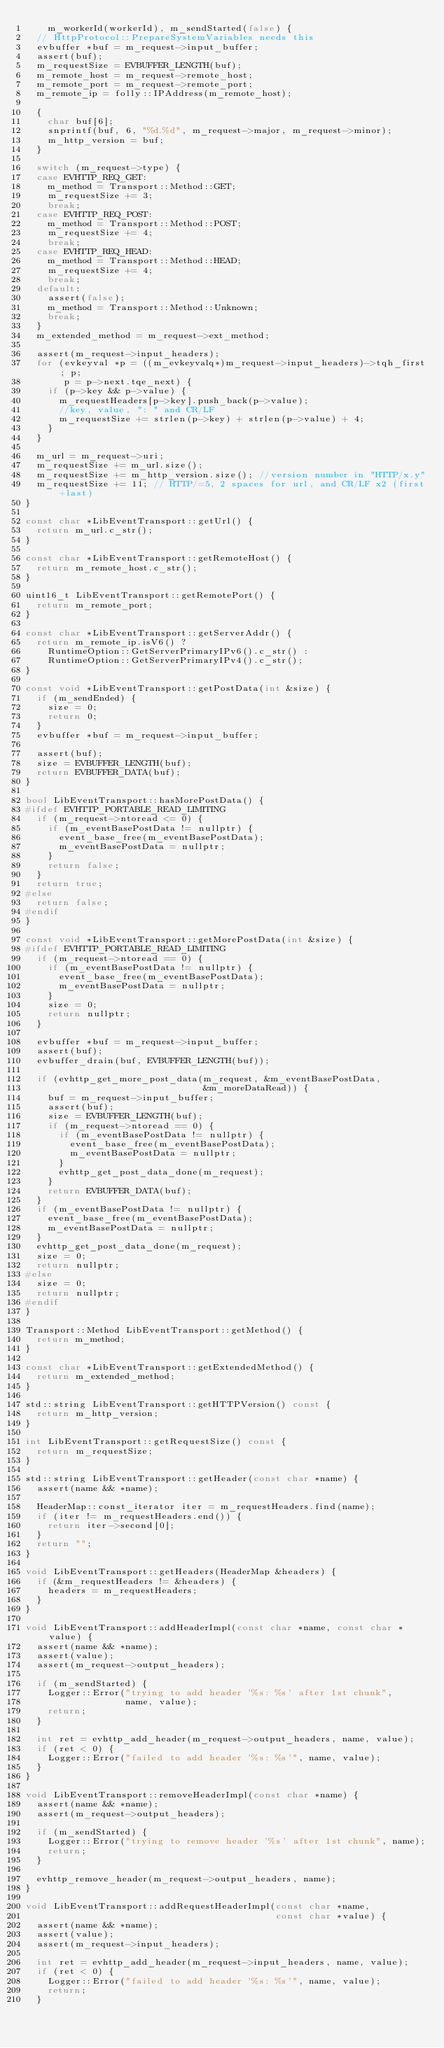Convert code to text. <code><loc_0><loc_0><loc_500><loc_500><_C++_>    m_workerId(workerId), m_sendStarted(false) {
  // HttpProtocol::PrepareSystemVariables needs this
  evbuffer *buf = m_request->input_buffer;
  assert(buf);
  m_requestSize = EVBUFFER_LENGTH(buf);
  m_remote_host = m_request->remote_host;
  m_remote_port = m_request->remote_port;
  m_remote_ip = folly::IPAddress(m_remote_host);

  {
    char buf[6];
    snprintf(buf, 6, "%d.%d", m_request->major, m_request->minor);
    m_http_version = buf;
  }

  switch (m_request->type) {
  case EVHTTP_REQ_GET:
    m_method = Transport::Method::GET;
    m_requestSize += 3;
    break;
  case EVHTTP_REQ_POST:
    m_method = Transport::Method::POST;
    m_requestSize += 4;
    break;
  case EVHTTP_REQ_HEAD:
    m_method = Transport::Method::HEAD;
    m_requestSize += 4;
    break;
  default:
    assert(false);
    m_method = Transport::Method::Unknown;
    break;
  }
  m_extended_method = m_request->ext_method;

  assert(m_request->input_headers);
  for (evkeyval *p = ((m_evkeyvalq*)m_request->input_headers)->tqh_first; p;
       p = p->next.tqe_next) {
    if (p->key && p->value) {
      m_requestHeaders[p->key].push_back(p->value);
      //key, value, ": " and CR/LF
      m_requestSize += strlen(p->key) + strlen(p->value) + 4;
    }
  }

  m_url = m_request->uri;
  m_requestSize += m_url.size();
  m_requestSize += m_http_version.size(); //version number in "HTTP/x.y"
  m_requestSize += 11; // HTTP/=5, 2 spaces for url, and CR/LF x2 (first+last)
}

const char *LibEventTransport::getUrl() {
  return m_url.c_str();
}

const char *LibEventTransport::getRemoteHost() {
  return m_remote_host.c_str();
}

uint16_t LibEventTransport::getRemotePort() {
  return m_remote_port;
}

const char *LibEventTransport::getServerAddr() {
  return m_remote_ip.isV6() ?
    RuntimeOption::GetServerPrimaryIPv6().c_str() :
    RuntimeOption::GetServerPrimaryIPv4().c_str();
}

const void *LibEventTransport::getPostData(int &size) {
  if (m_sendEnded) {
    size = 0;
    return 0;
  }
  evbuffer *buf = m_request->input_buffer;

  assert(buf);
  size = EVBUFFER_LENGTH(buf);
  return EVBUFFER_DATA(buf);
}

bool LibEventTransport::hasMorePostData() {
#ifdef EVHTTP_PORTABLE_READ_LIMITING
  if (m_request->ntoread <= 0) {
    if (m_eventBasePostData != nullptr) {
      event_base_free(m_eventBasePostData);
      m_eventBasePostData = nullptr;
    }
    return false;
  }
  return true;
#else
  return false;
#endif
}

const void *LibEventTransport::getMorePostData(int &size) {
#ifdef EVHTTP_PORTABLE_READ_LIMITING
  if (m_request->ntoread == 0) {
    if (m_eventBasePostData != nullptr) {
      event_base_free(m_eventBasePostData);
      m_eventBasePostData = nullptr;
    }
    size = 0;
    return nullptr;
  }

  evbuffer *buf = m_request->input_buffer;
  assert(buf);
  evbuffer_drain(buf, EVBUFFER_LENGTH(buf));

  if (evhttp_get_more_post_data(m_request, &m_eventBasePostData,
                                &m_moreDataRead)) {
    buf = m_request->input_buffer;
    assert(buf);
    size = EVBUFFER_LENGTH(buf);
    if (m_request->ntoread == 0) {
      if (m_eventBasePostData != nullptr) {
        event_base_free(m_eventBasePostData);
        m_eventBasePostData = nullptr;
      }
      evhttp_get_post_data_done(m_request);
    }
    return EVBUFFER_DATA(buf);
  }
  if (m_eventBasePostData != nullptr) {
    event_base_free(m_eventBasePostData);
    m_eventBasePostData = nullptr;
  }
  evhttp_get_post_data_done(m_request);
  size = 0;
  return nullptr;
#else
  size = 0;
  return nullptr;
#endif
}

Transport::Method LibEventTransport::getMethod() {
  return m_method;
}

const char *LibEventTransport::getExtendedMethod() {
  return m_extended_method;
}

std::string LibEventTransport::getHTTPVersion() const {
  return m_http_version;
}

int LibEventTransport::getRequestSize() const {
  return m_requestSize;
}

std::string LibEventTransport::getHeader(const char *name) {
  assert(name && *name);

  HeaderMap::const_iterator iter = m_requestHeaders.find(name);
  if (iter != m_requestHeaders.end()) {
    return iter->second[0];
  }
  return "";
}

void LibEventTransport::getHeaders(HeaderMap &headers) {
  if (&m_requestHeaders != &headers) {
    headers = m_requestHeaders;
  }
}

void LibEventTransport::addHeaderImpl(const char *name, const char *value) {
  assert(name && *name);
  assert(value);
  assert(m_request->output_headers);

  if (m_sendStarted) {
    Logger::Error("trying to add header '%s: %s' after 1st chunk",
                  name, value);
    return;
  }

  int ret = evhttp_add_header(m_request->output_headers, name, value);
  if (ret < 0) {
    Logger::Error("failed to add header '%s: %s'", name, value);
  }
}

void LibEventTransport::removeHeaderImpl(const char *name) {
  assert(name && *name);
  assert(m_request->output_headers);

  if (m_sendStarted) {
    Logger::Error("trying to remove header '%s' after 1st chunk", name);
    return;
  }

  evhttp_remove_header(m_request->output_headers, name);
}

void LibEventTransport::addRequestHeaderImpl(const char *name,
                                             const char *value) {
  assert(name && *name);
  assert(value);
  assert(m_request->input_headers);

  int ret = evhttp_add_header(m_request->input_headers, name, value);
  if (ret < 0) {
    Logger::Error("failed to add header '%s: %s'", name, value);
    return;
  }</code> 